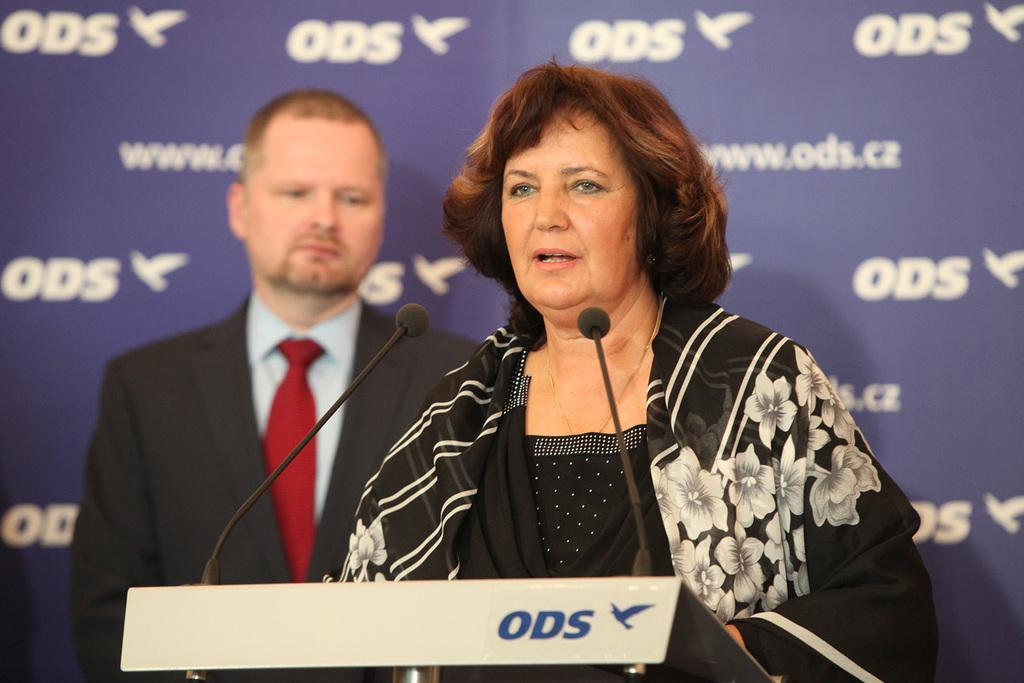How many people are present in the image? There is a man and a woman present in the image. What is the man and woman standing near in the image? They are standing near a podium in the image. What objects are used for amplifying sound in the image? There are microphones in the image. What can be seen written on a wall in the background of the image? There is something written on a wall in the background of the image. What type of ship can be seen in the image? There is no ship present in the image. How many credits are visible on the wall in the image? There is no mention of credits in the image; it only states that something is written on the wall. 